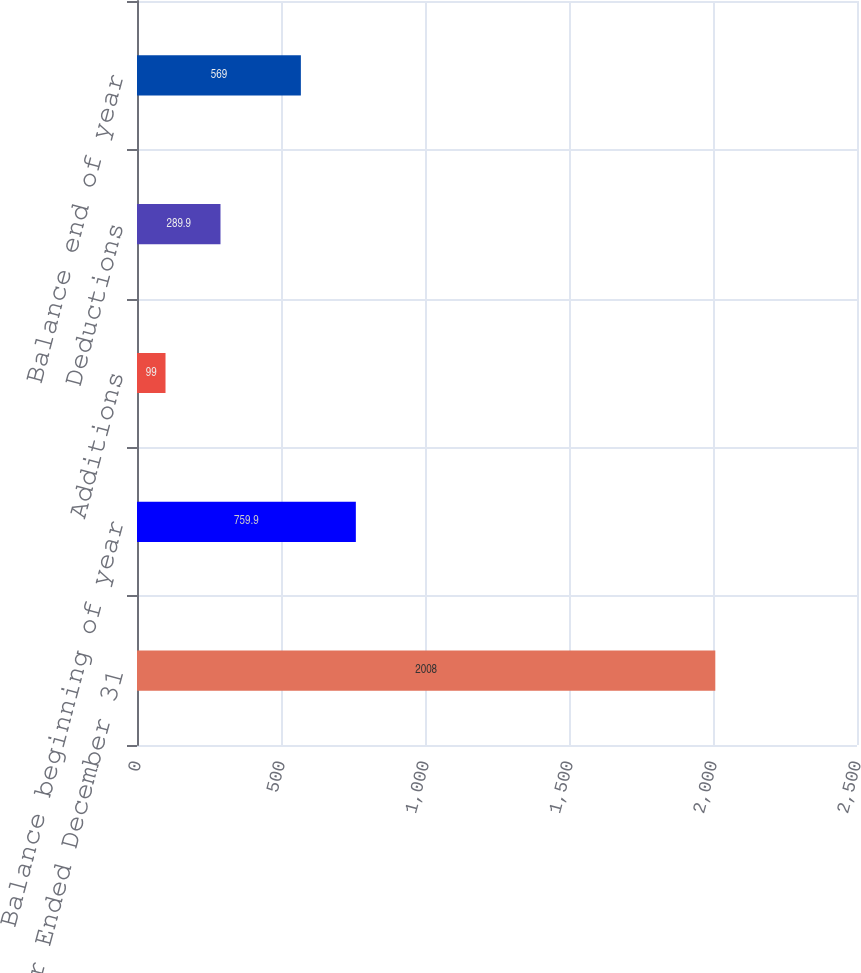<chart> <loc_0><loc_0><loc_500><loc_500><bar_chart><fcel>Year Ended December 31<fcel>Balance beginning of year<fcel>Additions<fcel>Deductions<fcel>Balance end of year<nl><fcel>2008<fcel>759.9<fcel>99<fcel>289.9<fcel>569<nl></chart> 